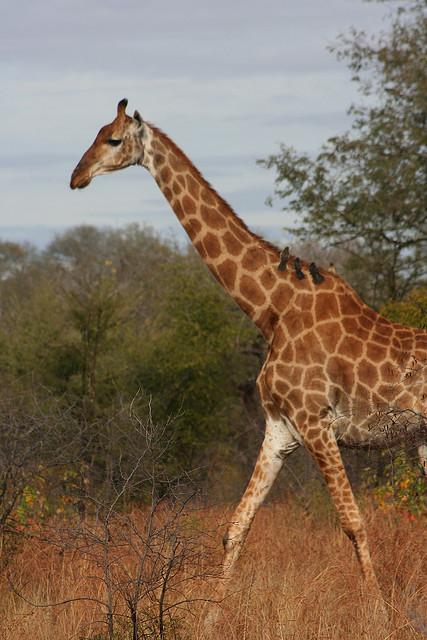Is the giraffe gentle?
Give a very brief answer. Yes. Overcast or sunny?
Quick response, please. Overcast. Is the giraffe in its natural habitat?
Be succinct. Yes. Is the tree on the right or the giraffe tallest?
Answer briefly. Tree. Is the giraffe facing the right?
Quick response, please. No. Are these animals free in the wild or in a zoo?
Answer briefly. Wild. 